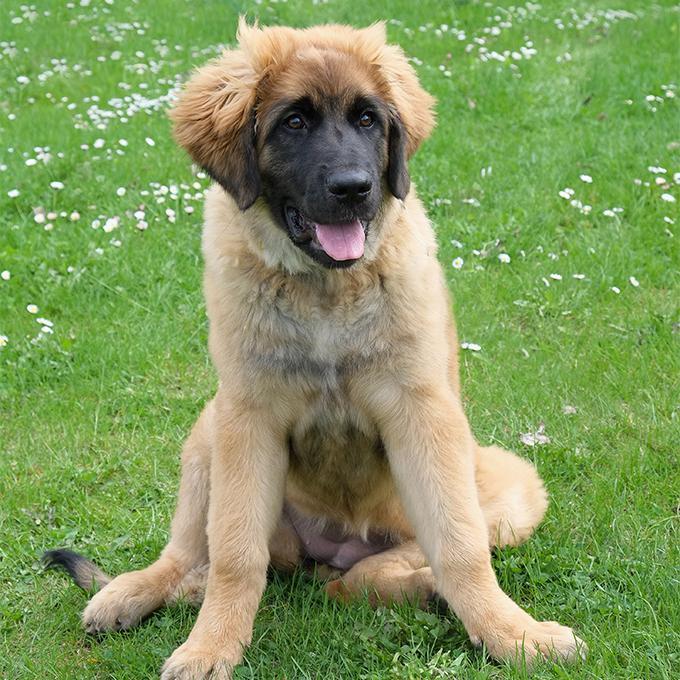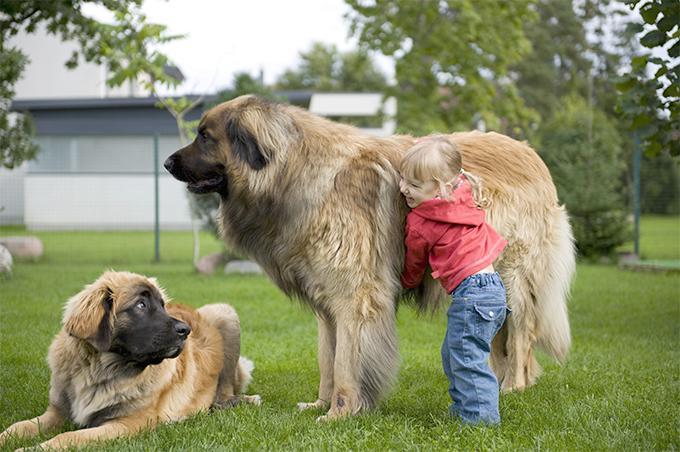The first image is the image on the left, the second image is the image on the right. For the images displayed, is the sentence "At least one human is pictured with dogs." factually correct? Answer yes or no. Yes. 